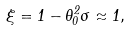Convert formula to latex. <formula><loc_0><loc_0><loc_500><loc_500>\xi = 1 - \theta _ { 0 } ^ { 2 } \sigma \approx 1 ,</formula> 